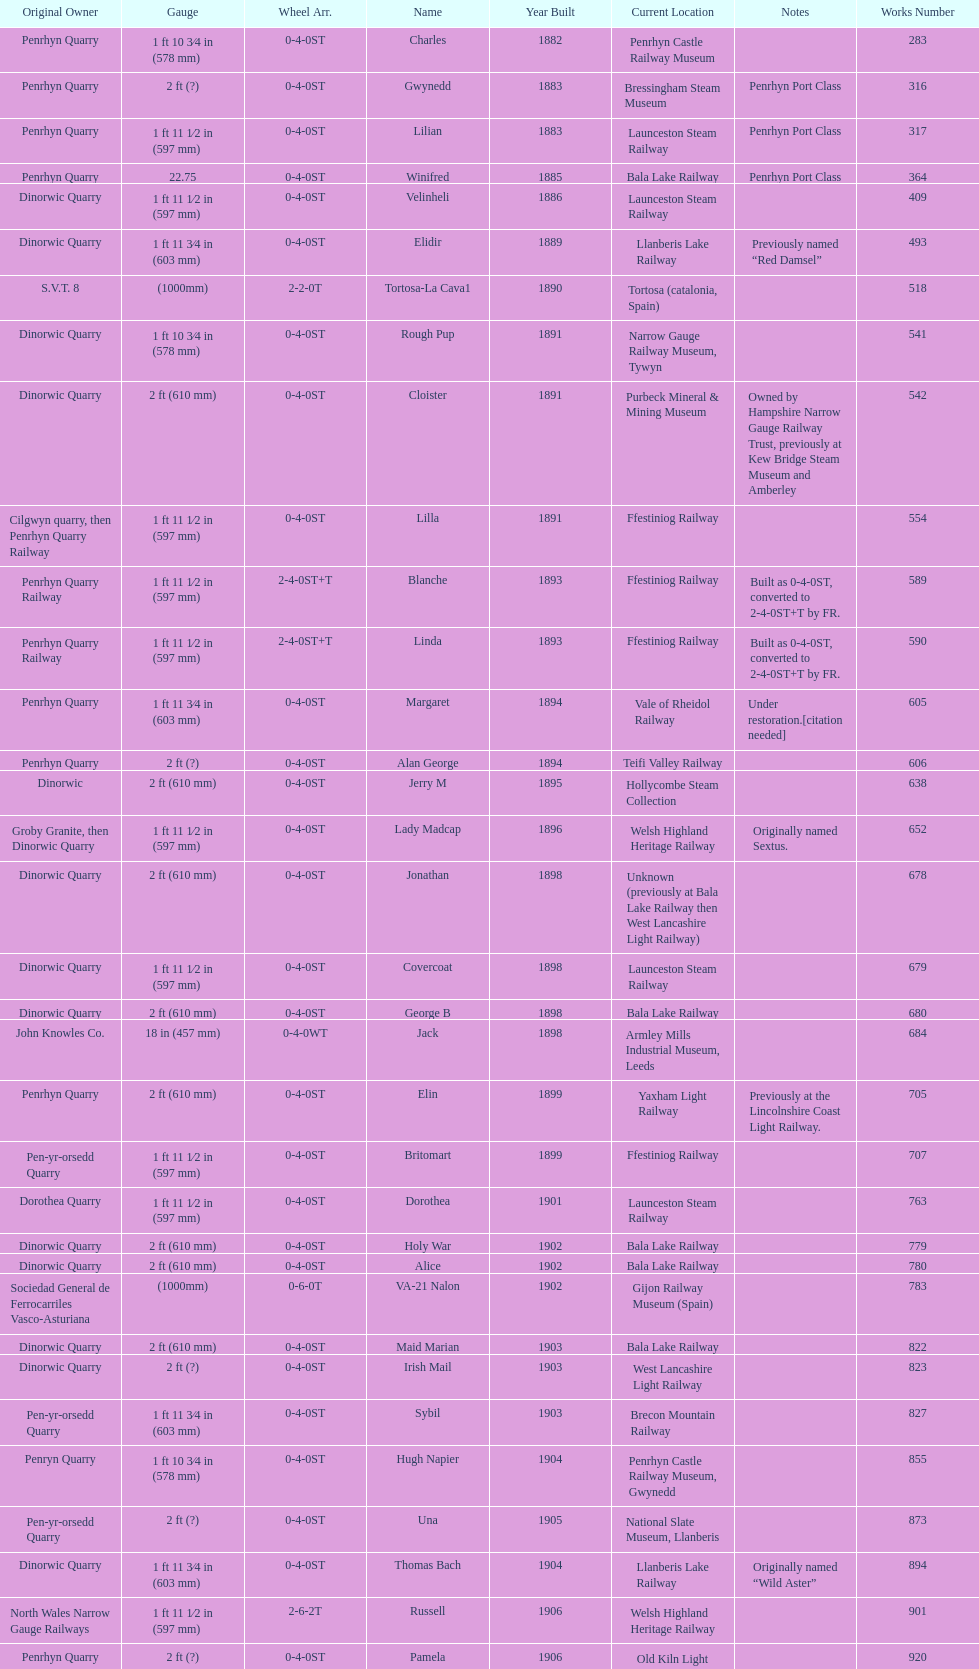In which year were the most steam locomotives built? 1898. 